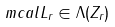<formula> <loc_0><loc_0><loc_500><loc_500>\ m c a l L _ { r } \in \Lambda ( Z _ { r } )</formula> 